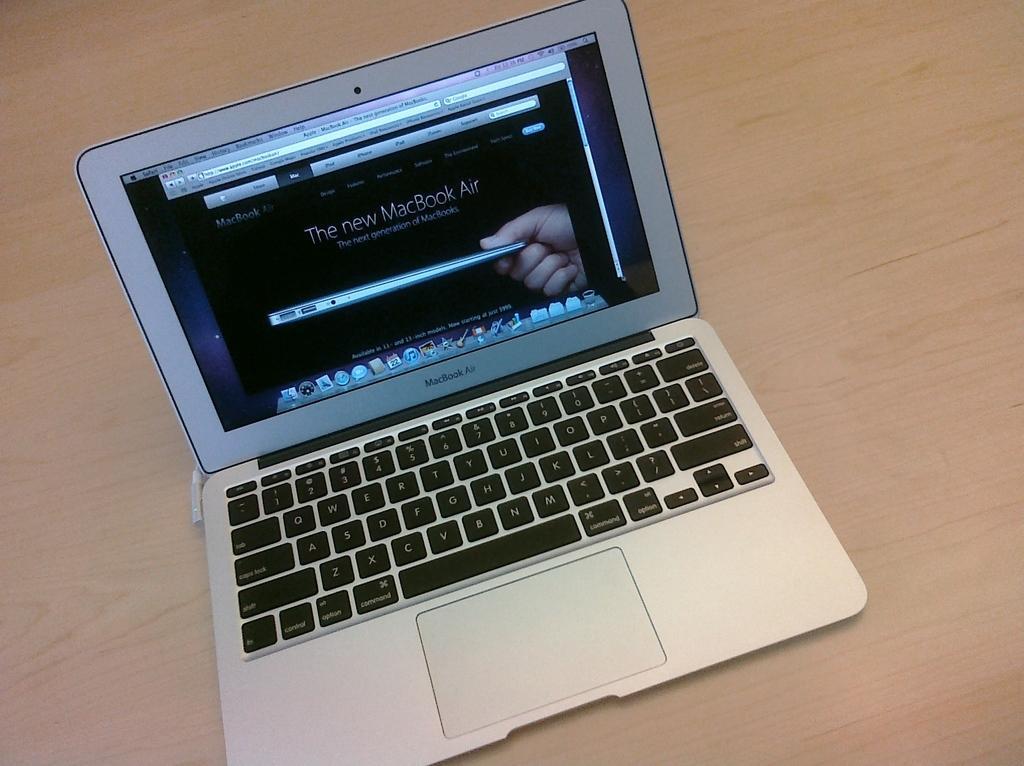Please provide a concise description of this image. In this image we can see a laptop on the wooden surface. 